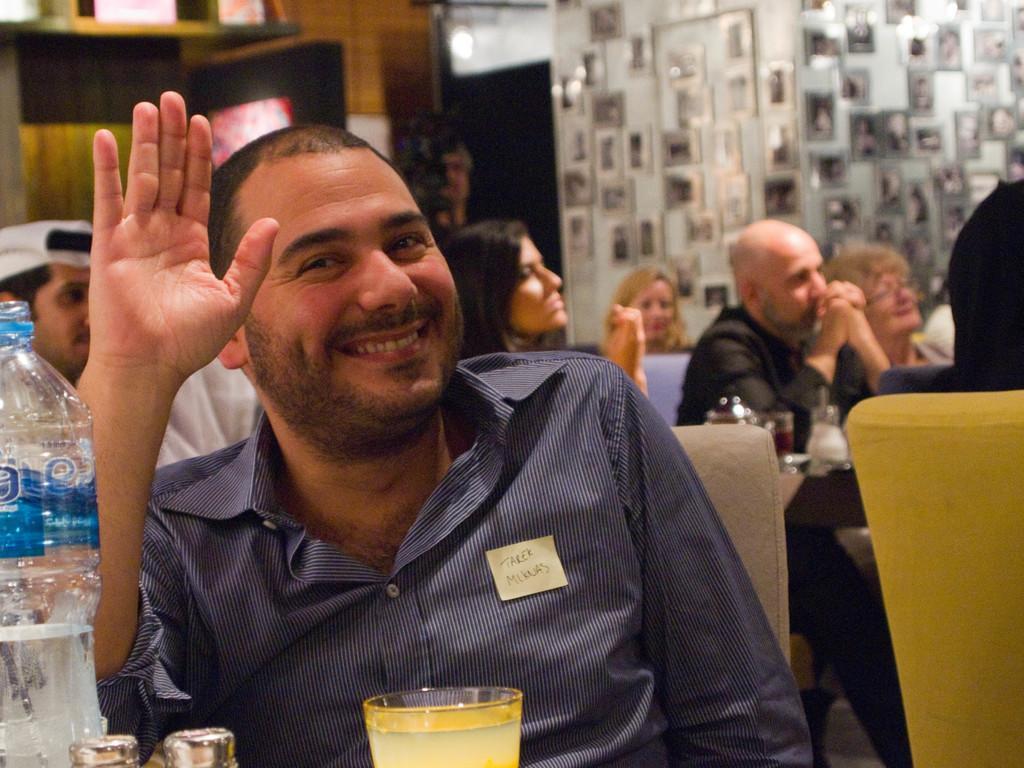Describe this image in one or two sentences. In this picture I can see a man who is sitting in front and I see that he is smiling and I can also see that he is wearing a shirt. In front of him I can see a bottle, 2 glasses and 2 brown color things. In the background I can see few people who are sitting on chairs and I can see the wall on which there are frames. In the middle of this picture I can see a person who is standing. 